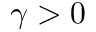<formula> <loc_0><loc_0><loc_500><loc_500>\gamma > 0</formula> 